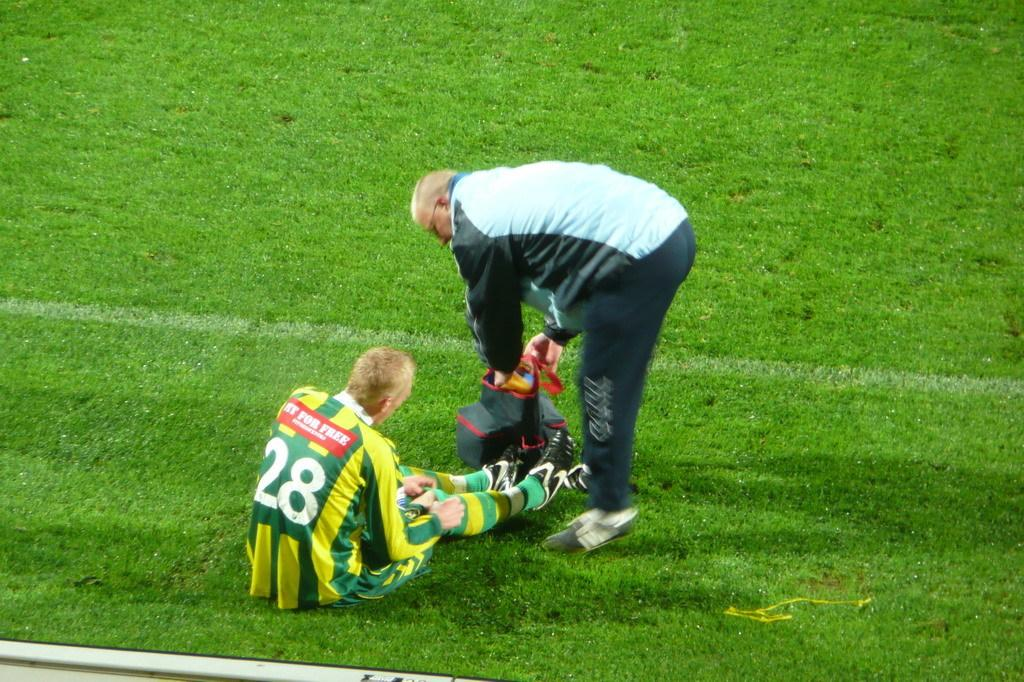How many people are in the image? There are two people in the image. What is on the ground near the people? There is a bag on the ground in the image. What type of terrain is visible in the image? Grass is present in the image. What type of bubble can be seen floating near the people in the image? There is no bubble present in the image. Can you see a bat flying in the sky in the image? There is no bat visible in the image. 